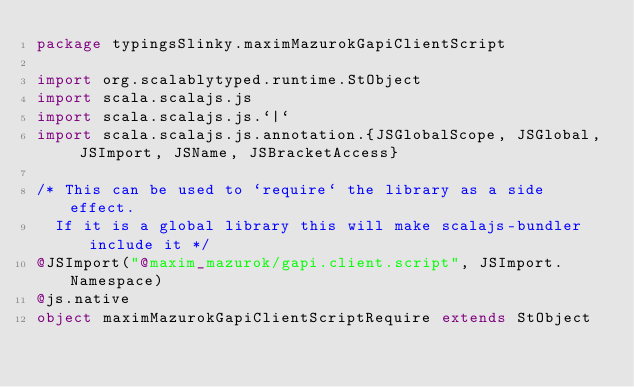Convert code to text. <code><loc_0><loc_0><loc_500><loc_500><_Scala_>package typingsSlinky.maximMazurokGapiClientScript

import org.scalablytyped.runtime.StObject
import scala.scalajs.js
import scala.scalajs.js.`|`
import scala.scalajs.js.annotation.{JSGlobalScope, JSGlobal, JSImport, JSName, JSBracketAccess}

/* This can be used to `require` the library as a side effect.
  If it is a global library this will make scalajs-bundler include it */
@JSImport("@maxim_mazurok/gapi.client.script", JSImport.Namespace)
@js.native
object maximMazurokGapiClientScriptRequire extends StObject
</code> 